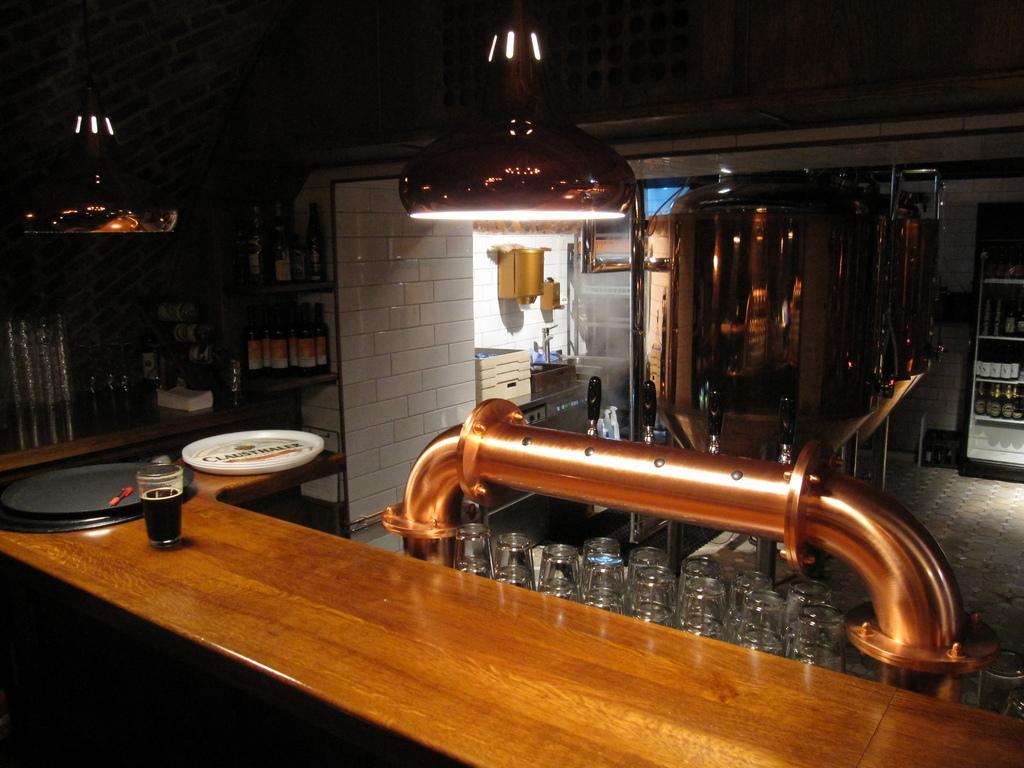Please provide a concise description of this image. in this picture we can see a mini bar,in which we can see the number of glasses bottles,fridge and light ,here on table we can see glass with full liquid. 